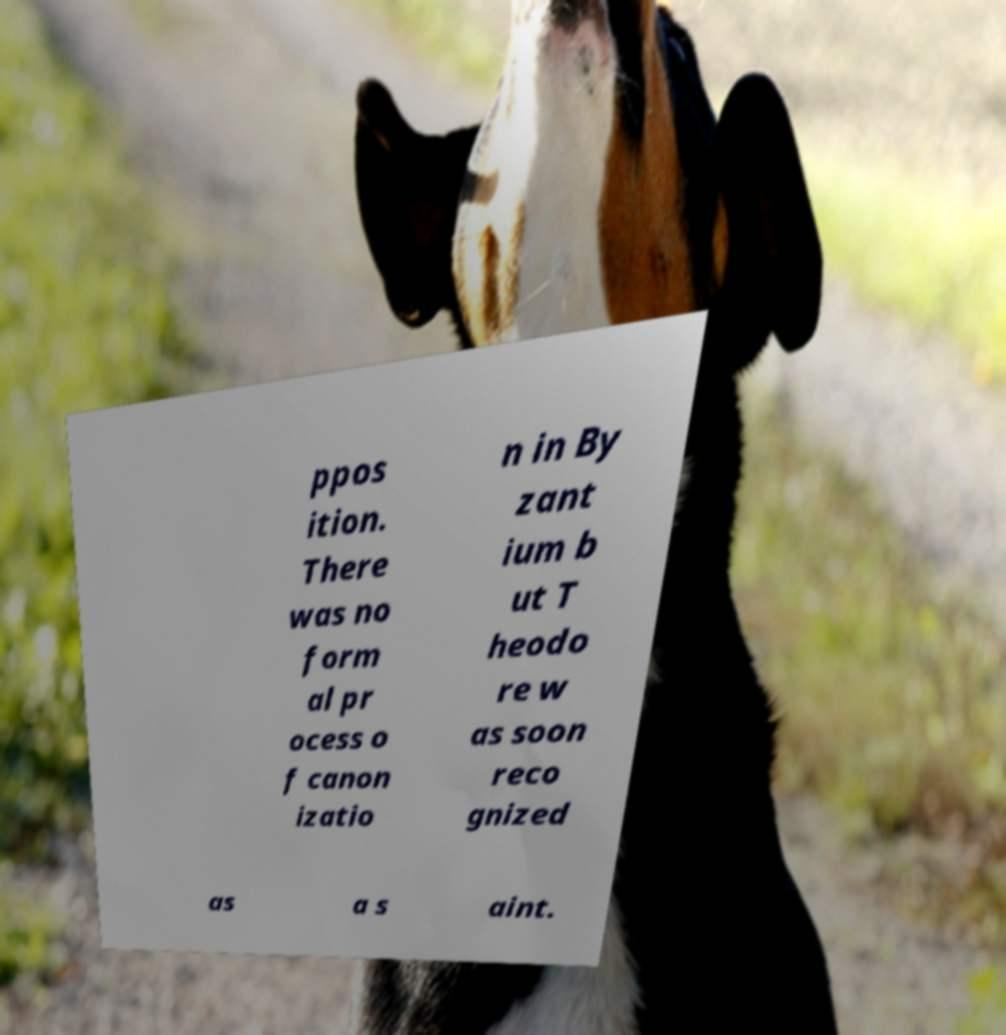Please read and relay the text visible in this image. What does it say? ppos ition. There was no form al pr ocess o f canon izatio n in By zant ium b ut T heodo re w as soon reco gnized as a s aint. 